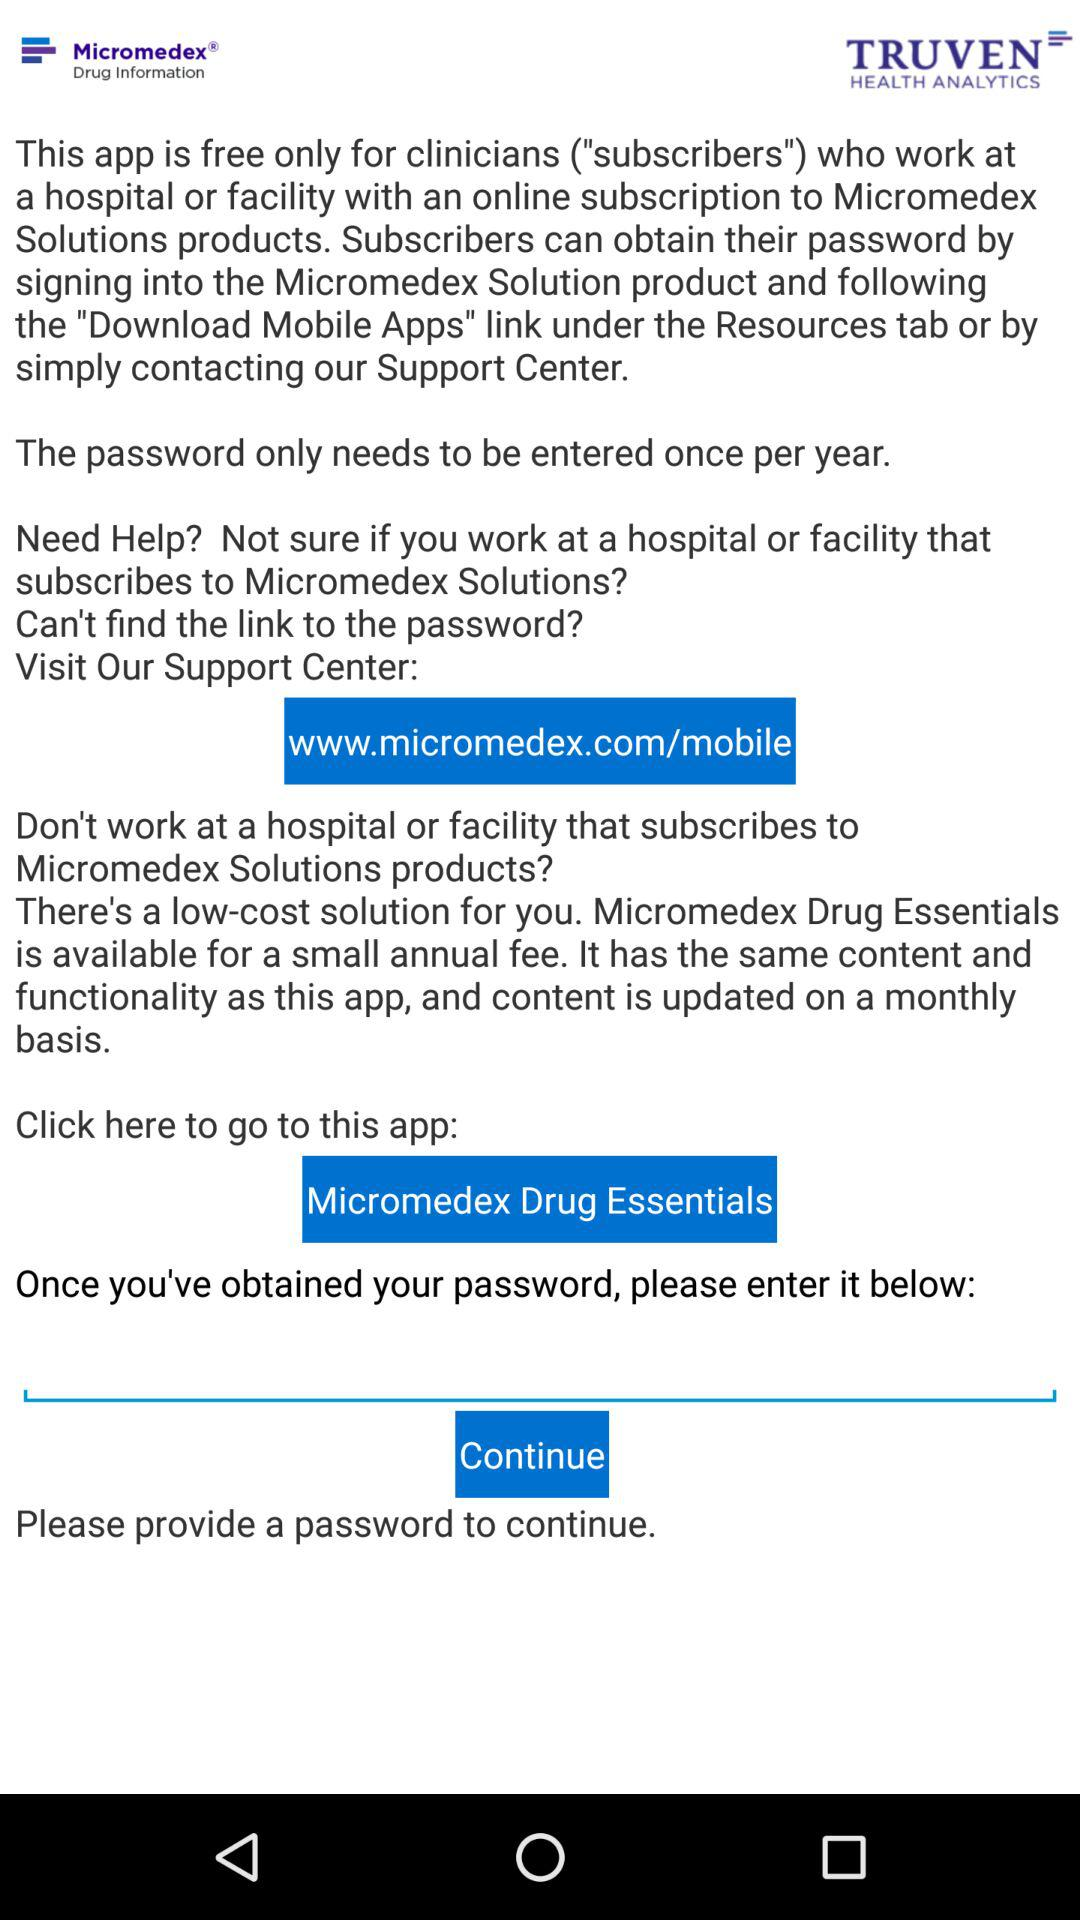What is the app name? The app name is "Micromedex Drug Information". 